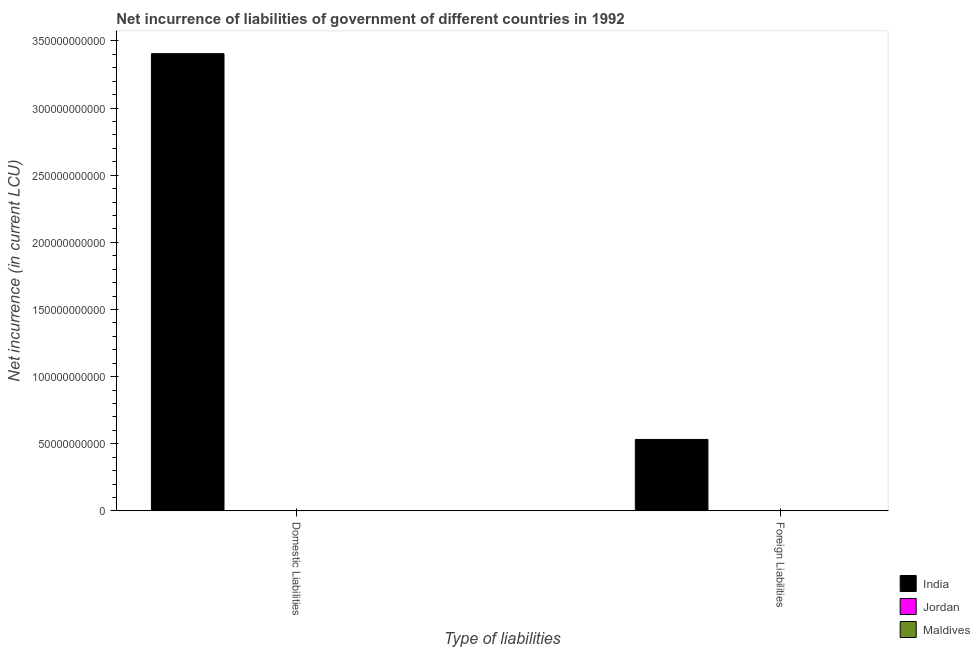How many different coloured bars are there?
Give a very brief answer. 3. How many bars are there on the 2nd tick from the right?
Provide a short and direct response. 2. What is the label of the 1st group of bars from the left?
Your answer should be compact. Domestic Liabilities. What is the net incurrence of foreign liabilities in Maldives?
Provide a succinct answer. 1.67e+08. Across all countries, what is the maximum net incurrence of domestic liabilities?
Provide a succinct answer. 3.41e+11. In which country was the net incurrence of domestic liabilities maximum?
Offer a very short reply. India. What is the total net incurrence of foreign liabilities in the graph?
Your answer should be very brief. 5.36e+1. What is the difference between the net incurrence of foreign liabilities in Maldives and that in India?
Ensure brevity in your answer.  -5.30e+1. What is the difference between the net incurrence of foreign liabilities in Maldives and the net incurrence of domestic liabilities in Jordan?
Provide a short and direct response. 1.67e+08. What is the average net incurrence of domestic liabilities per country?
Offer a very short reply. 1.14e+11. What is the difference between the net incurrence of domestic liabilities and net incurrence of foreign liabilities in India?
Offer a very short reply. 2.87e+11. What is the ratio of the net incurrence of foreign liabilities in Maldives to that in Jordan?
Provide a short and direct response. 0.8. In how many countries, is the net incurrence of domestic liabilities greater than the average net incurrence of domestic liabilities taken over all countries?
Offer a terse response. 1. Are all the bars in the graph horizontal?
Keep it short and to the point. No. How many countries are there in the graph?
Keep it short and to the point. 3. What is the difference between two consecutive major ticks on the Y-axis?
Offer a terse response. 5.00e+1. Where does the legend appear in the graph?
Provide a short and direct response. Bottom right. How many legend labels are there?
Ensure brevity in your answer.  3. What is the title of the graph?
Provide a short and direct response. Net incurrence of liabilities of government of different countries in 1992. Does "Heavily indebted poor countries" appear as one of the legend labels in the graph?
Your answer should be very brief. No. What is the label or title of the X-axis?
Your answer should be very brief. Type of liabilities. What is the label or title of the Y-axis?
Offer a very short reply. Net incurrence (in current LCU). What is the Net incurrence (in current LCU) of India in Domestic Liabilities?
Offer a very short reply. 3.41e+11. What is the Net incurrence (in current LCU) of Maldives in Domestic Liabilities?
Keep it short and to the point. 2.00e+08. What is the Net incurrence (in current LCU) in India in Foreign Liabilities?
Keep it short and to the point. 5.32e+1. What is the Net incurrence (in current LCU) of Jordan in Foreign Liabilities?
Make the answer very short. 2.09e+08. What is the Net incurrence (in current LCU) of Maldives in Foreign Liabilities?
Your answer should be compact. 1.67e+08. Across all Type of liabilities, what is the maximum Net incurrence (in current LCU) of India?
Your response must be concise. 3.41e+11. Across all Type of liabilities, what is the maximum Net incurrence (in current LCU) in Jordan?
Your response must be concise. 2.09e+08. Across all Type of liabilities, what is the maximum Net incurrence (in current LCU) of Maldives?
Give a very brief answer. 2.00e+08. Across all Type of liabilities, what is the minimum Net incurrence (in current LCU) of India?
Offer a terse response. 5.32e+1. Across all Type of liabilities, what is the minimum Net incurrence (in current LCU) of Maldives?
Provide a succinct answer. 1.67e+08. What is the total Net incurrence (in current LCU) in India in the graph?
Your answer should be very brief. 3.94e+11. What is the total Net incurrence (in current LCU) in Jordan in the graph?
Give a very brief answer. 2.09e+08. What is the total Net incurrence (in current LCU) of Maldives in the graph?
Offer a terse response. 3.67e+08. What is the difference between the Net incurrence (in current LCU) of India in Domestic Liabilities and that in Foreign Liabilities?
Your answer should be very brief. 2.87e+11. What is the difference between the Net incurrence (in current LCU) of Maldives in Domestic Liabilities and that in Foreign Liabilities?
Your answer should be compact. 3.33e+07. What is the difference between the Net incurrence (in current LCU) in India in Domestic Liabilities and the Net incurrence (in current LCU) in Jordan in Foreign Liabilities?
Ensure brevity in your answer.  3.40e+11. What is the difference between the Net incurrence (in current LCU) in India in Domestic Liabilities and the Net incurrence (in current LCU) in Maldives in Foreign Liabilities?
Your response must be concise. 3.40e+11. What is the average Net incurrence (in current LCU) of India per Type of liabilities?
Your answer should be very brief. 1.97e+11. What is the average Net incurrence (in current LCU) in Jordan per Type of liabilities?
Provide a succinct answer. 1.04e+08. What is the average Net incurrence (in current LCU) of Maldives per Type of liabilities?
Your answer should be compact. 1.84e+08. What is the difference between the Net incurrence (in current LCU) of India and Net incurrence (in current LCU) of Maldives in Domestic Liabilities?
Make the answer very short. 3.40e+11. What is the difference between the Net incurrence (in current LCU) in India and Net incurrence (in current LCU) in Jordan in Foreign Liabilities?
Keep it short and to the point. 5.30e+1. What is the difference between the Net incurrence (in current LCU) of India and Net incurrence (in current LCU) of Maldives in Foreign Liabilities?
Make the answer very short. 5.30e+1. What is the difference between the Net incurrence (in current LCU) of Jordan and Net incurrence (in current LCU) of Maldives in Foreign Liabilities?
Provide a succinct answer. 4.16e+07. What is the ratio of the Net incurrence (in current LCU) of India in Domestic Liabilities to that in Foreign Liabilities?
Ensure brevity in your answer.  6.4. What is the ratio of the Net incurrence (in current LCU) of Maldives in Domestic Liabilities to that in Foreign Liabilities?
Your answer should be very brief. 1.2. What is the difference between the highest and the second highest Net incurrence (in current LCU) in India?
Your answer should be compact. 2.87e+11. What is the difference between the highest and the second highest Net incurrence (in current LCU) of Maldives?
Your response must be concise. 3.33e+07. What is the difference between the highest and the lowest Net incurrence (in current LCU) of India?
Ensure brevity in your answer.  2.87e+11. What is the difference between the highest and the lowest Net incurrence (in current LCU) of Jordan?
Ensure brevity in your answer.  2.09e+08. What is the difference between the highest and the lowest Net incurrence (in current LCU) of Maldives?
Provide a succinct answer. 3.33e+07. 